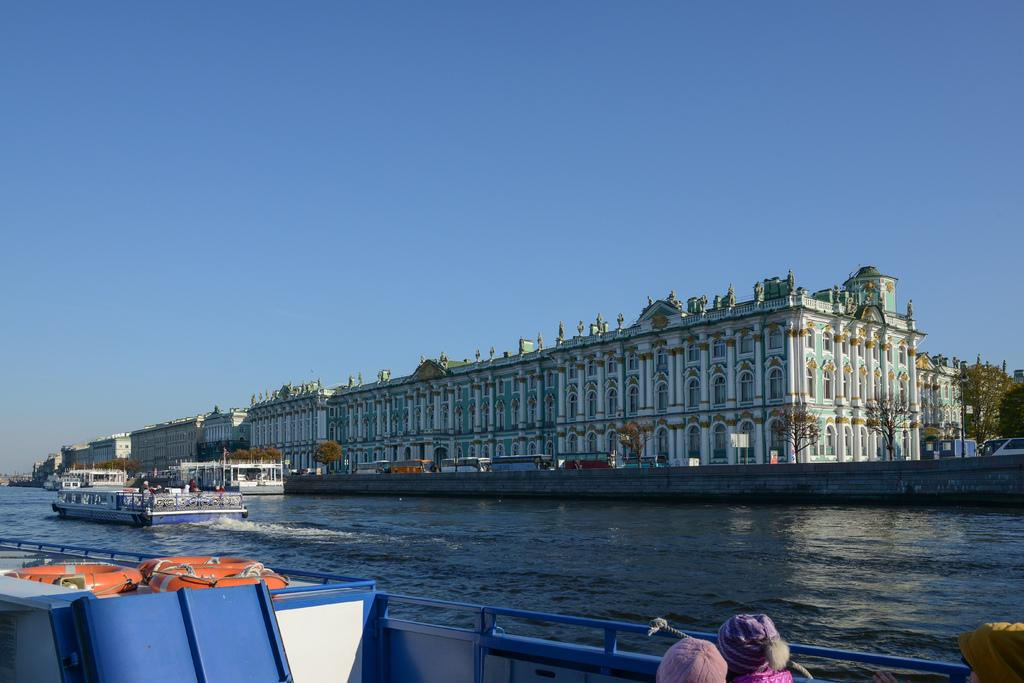What type of structures can be seen in the image? There are buildings in the image. What else can be seen in the image besides buildings? There are trees and ships on the water in the image. What are the people in the ships doing? People are sitting in the ships. What part of the natural environment is visible in the image? The sky is visible in the image. Who is the owner of the banana in the image? There is no banana present in the image, so it is not possible to determine the owner. 